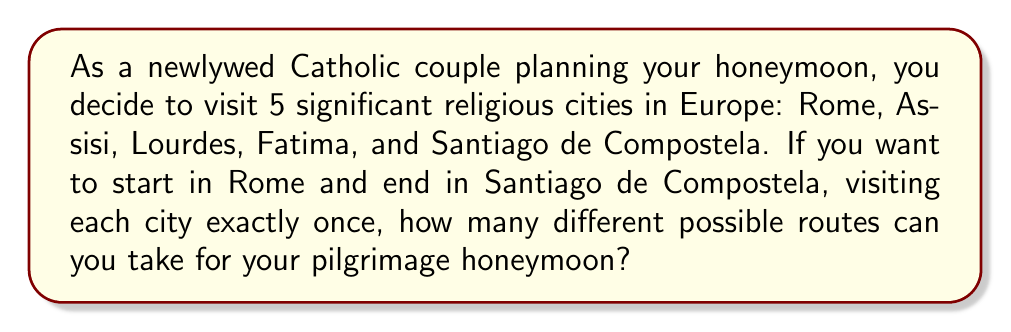Could you help me with this problem? Let's approach this step-by-step:

1) We start with Rome and end with Santiago de Compostela, so these cities are fixed in our sequence.

2) We need to arrange the other 3 cities (Assisi, Lourdes, and Fatima) in between Rome and Santiago de Compostela.

3) This is a permutation problem. We are arranging 3 items (the 3 middle cities) in all possible orders.

4) The number of permutations of n distinct objects is given by the factorial of n, denoted as n!

5) In this case, n = 3, so we're looking for 3!

6) Let's calculate 3!:
   $$3! = 3 \times 2 \times 1 = 6$$

Therefore, there are 6 different possible routes for the honeymoon pilgrimage.

To illustrate, these are the 6 possible routes:
1. Rome - Assisi - Lourdes - Fatima - Santiago de Compostela
2. Rome - Assisi - Fatima - Lourdes - Santiago de Compostela
3. Rome - Lourdes - Assisi - Fatima - Santiago de Compostela
4. Rome - Lourdes - Fatima - Assisi - Santiago de Compostela
5. Rome - Fatima - Assisi - Lourdes - Santiago de Compostela
6. Rome - Fatima - Lourdes - Assisi - Santiago de Compostela
Answer: 6 